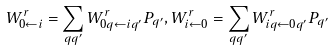<formula> <loc_0><loc_0><loc_500><loc_500>W ^ { r } _ { 0 \leftarrow i } = \sum _ { q q ^ { \prime } } W ^ { r } _ { 0 q \leftarrow i q ^ { \prime } } P _ { q ^ { \prime } } , W ^ { r } _ { i \leftarrow 0 } = \sum _ { q q ^ { \prime } } W ^ { r } _ { i q \leftarrow 0 q ^ { \prime } } P _ { q ^ { \prime } }</formula> 